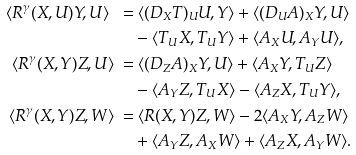<formula> <loc_0><loc_0><loc_500><loc_500>\langle R ^ { \gamma } ( X , U ) Y , U \rangle \ = & \ \langle ( D _ { X } T ) _ { U } U , Y \rangle + \langle ( D _ { U } A ) _ { X } Y , U \rangle \\ & - \langle T _ { U } X , T _ { U } Y \rangle + \langle A _ { X } U , A _ { Y } U \rangle , \\ \langle R ^ { \gamma } ( X , Y ) Z , U \rangle \ = & \ \langle ( D _ { Z } A ) _ { X } Y , U \rangle + \langle A _ { X } Y , T _ { U } Z \rangle \\ & - \langle A _ { Y } Z , T _ { U } X \rangle - \langle A _ { Z } X , T _ { U } Y \rangle , \\ \langle R ^ { \gamma } ( X , Y ) Z , W \rangle \ = & \ \langle R ( X , Y ) Z , W \rangle - 2 \langle A _ { X } Y , A _ { Z } W \rangle \\ & + \langle A _ { Y } Z , A _ { X } W \rangle + \langle A _ { Z } X , A _ { Y } W \rangle .</formula> 